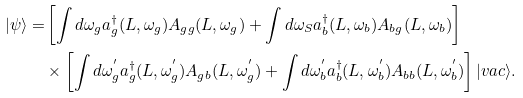Convert formula to latex. <formula><loc_0><loc_0><loc_500><loc_500>| \psi \rangle = & \left [ \int d \omega _ { g } a _ { g } ^ { \dagger } ( L , \omega _ { g } ) A _ { g g } ( L , \omega _ { g } ) + \int d \omega _ { S } a _ { b } ^ { \dagger } ( L , \omega _ { b } ) A _ { b g } ( L , \omega _ { b } ) \right ] \\ & \times \left [ \int d \omega _ { g } ^ { ^ { \prime } } a _ { g } ^ { \dagger } ( L , \omega _ { g } ^ { ^ { \prime } } ) A _ { g b } ( L , \omega _ { g } ^ { ^ { \prime } } ) + \int d \omega _ { b } ^ { ^ { \prime } } a _ { b } ^ { \dagger } ( L , \omega _ { b } ^ { ^ { \prime } } ) A _ { b b } ( L , \omega _ { b } ^ { ^ { \prime } } ) \right ] | v a c \rangle .</formula> 